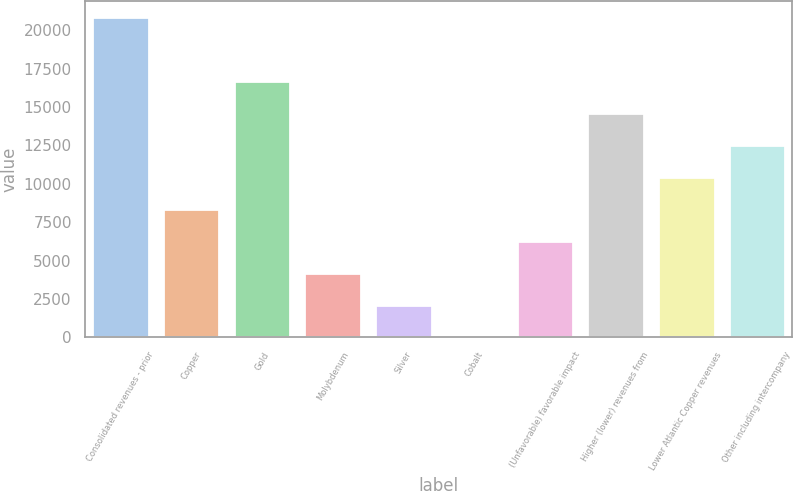<chart> <loc_0><loc_0><loc_500><loc_500><bar_chart><fcel>Consolidated revenues - prior<fcel>Copper<fcel>Gold<fcel>Molybdenum<fcel>Silver<fcel>Cobalt<fcel>(Unfavorable) favorable impact<fcel>Higher (lower) revenues from<fcel>Lower Atlantic Copper revenues<fcel>Other including intercompany<nl><fcel>20880<fcel>8355.6<fcel>16705.2<fcel>4180.8<fcel>2093.4<fcel>6<fcel>6268.2<fcel>14617.8<fcel>10443<fcel>12530.4<nl></chart> 